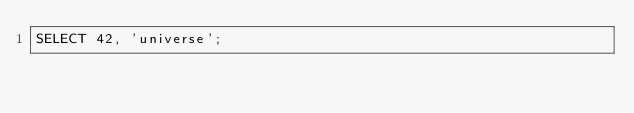<code> <loc_0><loc_0><loc_500><loc_500><_SQL_>SELECT 42, 'universe';
</code> 